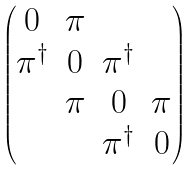Convert formula to latex. <formula><loc_0><loc_0><loc_500><loc_500>\begin{pmatrix} 0 & \pi & & \\ \pi ^ { \dagger } & 0 & \pi ^ { \dagger } & \\ & \pi & 0 & \pi \\ & & \pi ^ { \dagger } & 0 \\ \end{pmatrix}</formula> 